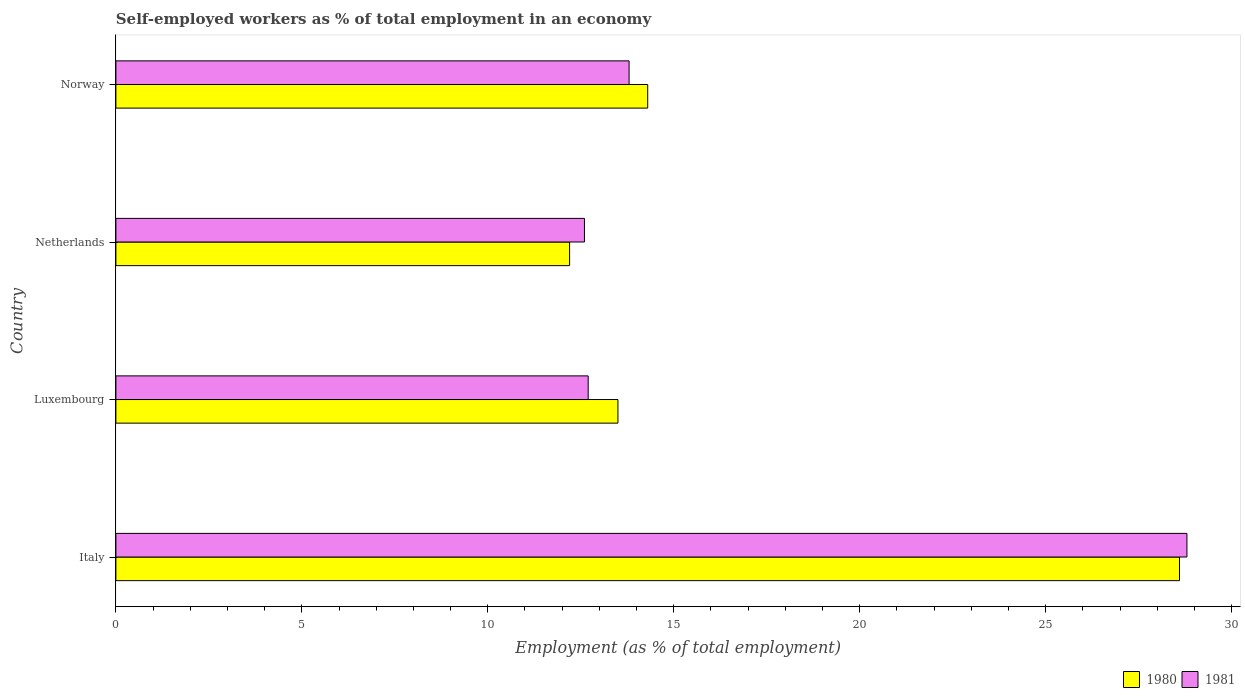How many different coloured bars are there?
Keep it short and to the point. 2. How many groups of bars are there?
Your answer should be very brief. 4. Are the number of bars per tick equal to the number of legend labels?
Provide a short and direct response. Yes. What is the label of the 4th group of bars from the top?
Your answer should be compact. Italy. In how many cases, is the number of bars for a given country not equal to the number of legend labels?
Your response must be concise. 0. What is the percentage of self-employed workers in 1980 in Norway?
Your response must be concise. 14.3. Across all countries, what is the maximum percentage of self-employed workers in 1980?
Your response must be concise. 28.6. Across all countries, what is the minimum percentage of self-employed workers in 1981?
Your answer should be compact. 12.6. In which country was the percentage of self-employed workers in 1980 minimum?
Make the answer very short. Netherlands. What is the total percentage of self-employed workers in 1981 in the graph?
Your answer should be very brief. 67.9. What is the difference between the percentage of self-employed workers in 1981 in Luxembourg and that in Norway?
Offer a very short reply. -1.1. What is the difference between the percentage of self-employed workers in 1980 in Luxembourg and the percentage of self-employed workers in 1981 in Netherlands?
Offer a terse response. 0.9. What is the average percentage of self-employed workers in 1981 per country?
Make the answer very short. 16.97. What is the difference between the percentage of self-employed workers in 1981 and percentage of self-employed workers in 1980 in Italy?
Make the answer very short. 0.2. In how many countries, is the percentage of self-employed workers in 1980 greater than 28 %?
Offer a terse response. 1. What is the ratio of the percentage of self-employed workers in 1981 in Italy to that in Luxembourg?
Provide a short and direct response. 2.27. Is the percentage of self-employed workers in 1981 in Luxembourg less than that in Netherlands?
Provide a short and direct response. No. What is the difference between the highest and the second highest percentage of self-employed workers in 1981?
Provide a succinct answer. 15. What is the difference between the highest and the lowest percentage of self-employed workers in 1980?
Your response must be concise. 16.4. What does the 2nd bar from the top in Luxembourg represents?
Keep it short and to the point. 1980. What does the 1st bar from the bottom in Italy represents?
Give a very brief answer. 1980. How many countries are there in the graph?
Give a very brief answer. 4. Where does the legend appear in the graph?
Provide a succinct answer. Bottom right. What is the title of the graph?
Provide a short and direct response. Self-employed workers as % of total employment in an economy. What is the label or title of the X-axis?
Offer a very short reply. Employment (as % of total employment). What is the label or title of the Y-axis?
Give a very brief answer. Country. What is the Employment (as % of total employment) of 1980 in Italy?
Offer a very short reply. 28.6. What is the Employment (as % of total employment) of 1981 in Italy?
Provide a succinct answer. 28.8. What is the Employment (as % of total employment) of 1981 in Luxembourg?
Keep it short and to the point. 12.7. What is the Employment (as % of total employment) of 1980 in Netherlands?
Your response must be concise. 12.2. What is the Employment (as % of total employment) of 1981 in Netherlands?
Offer a very short reply. 12.6. What is the Employment (as % of total employment) of 1980 in Norway?
Your response must be concise. 14.3. What is the Employment (as % of total employment) of 1981 in Norway?
Ensure brevity in your answer.  13.8. Across all countries, what is the maximum Employment (as % of total employment) in 1980?
Offer a very short reply. 28.6. Across all countries, what is the maximum Employment (as % of total employment) in 1981?
Make the answer very short. 28.8. Across all countries, what is the minimum Employment (as % of total employment) in 1980?
Provide a short and direct response. 12.2. Across all countries, what is the minimum Employment (as % of total employment) of 1981?
Offer a terse response. 12.6. What is the total Employment (as % of total employment) in 1980 in the graph?
Your response must be concise. 68.6. What is the total Employment (as % of total employment) of 1981 in the graph?
Ensure brevity in your answer.  67.9. What is the difference between the Employment (as % of total employment) of 1980 in Italy and that in Luxembourg?
Provide a short and direct response. 15.1. What is the difference between the Employment (as % of total employment) in 1980 in Italy and that in Netherlands?
Keep it short and to the point. 16.4. What is the difference between the Employment (as % of total employment) in 1981 in Italy and that in Netherlands?
Make the answer very short. 16.2. What is the difference between the Employment (as % of total employment) of 1980 in Luxembourg and that in Netherlands?
Your answer should be very brief. 1.3. What is the difference between the Employment (as % of total employment) in 1981 in Luxembourg and that in Netherlands?
Your answer should be very brief. 0.1. What is the difference between the Employment (as % of total employment) in 1980 in Italy and the Employment (as % of total employment) in 1981 in Luxembourg?
Your response must be concise. 15.9. What is the difference between the Employment (as % of total employment) of 1980 in Italy and the Employment (as % of total employment) of 1981 in Netherlands?
Keep it short and to the point. 16. What is the average Employment (as % of total employment) of 1980 per country?
Your response must be concise. 17.15. What is the average Employment (as % of total employment) of 1981 per country?
Provide a succinct answer. 16.98. What is the difference between the Employment (as % of total employment) of 1980 and Employment (as % of total employment) of 1981 in Italy?
Keep it short and to the point. -0.2. What is the ratio of the Employment (as % of total employment) in 1980 in Italy to that in Luxembourg?
Your answer should be compact. 2.12. What is the ratio of the Employment (as % of total employment) in 1981 in Italy to that in Luxembourg?
Give a very brief answer. 2.27. What is the ratio of the Employment (as % of total employment) of 1980 in Italy to that in Netherlands?
Your response must be concise. 2.34. What is the ratio of the Employment (as % of total employment) in 1981 in Italy to that in Netherlands?
Your answer should be very brief. 2.29. What is the ratio of the Employment (as % of total employment) in 1980 in Italy to that in Norway?
Provide a short and direct response. 2. What is the ratio of the Employment (as % of total employment) of 1981 in Italy to that in Norway?
Offer a terse response. 2.09. What is the ratio of the Employment (as % of total employment) of 1980 in Luxembourg to that in Netherlands?
Offer a very short reply. 1.11. What is the ratio of the Employment (as % of total employment) of 1981 in Luxembourg to that in Netherlands?
Give a very brief answer. 1.01. What is the ratio of the Employment (as % of total employment) in 1980 in Luxembourg to that in Norway?
Ensure brevity in your answer.  0.94. What is the ratio of the Employment (as % of total employment) in 1981 in Luxembourg to that in Norway?
Your response must be concise. 0.92. What is the ratio of the Employment (as % of total employment) of 1980 in Netherlands to that in Norway?
Offer a very short reply. 0.85. What is the difference between the highest and the second highest Employment (as % of total employment) in 1981?
Your answer should be compact. 15. What is the difference between the highest and the lowest Employment (as % of total employment) of 1980?
Your answer should be very brief. 16.4. 